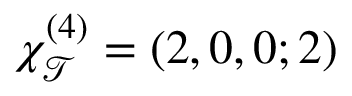Convert formula to latex. <formula><loc_0><loc_0><loc_500><loc_500>\chi _ { \mathcal { T } } ^ { ( 4 ) } = ( 2 , 0 , 0 ; 2 )</formula> 